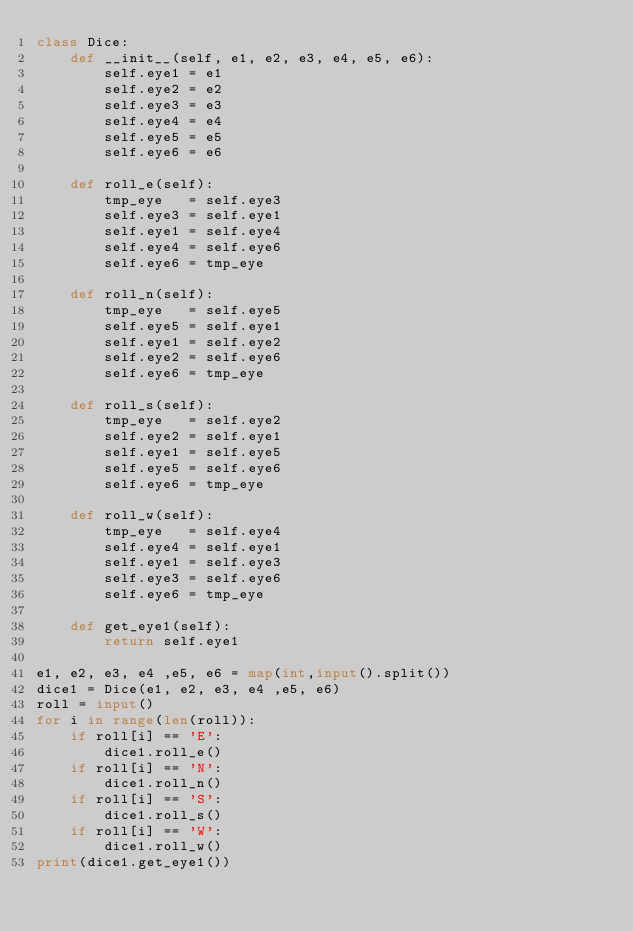Convert code to text. <code><loc_0><loc_0><loc_500><loc_500><_Python_>class Dice:
    def __init__(self, e1, e2, e3, e4, e5, e6):
        self.eye1 = e1
        self.eye2 = e2
        self.eye3 = e3
        self.eye4 = e4
        self.eye5 = e5
        self.eye6 = e6
    
    def roll_e(self):
        tmp_eye   = self.eye3
        self.eye3 = self.eye1
        self.eye1 = self.eye4
        self.eye4 = self.eye6
        self.eye6 = tmp_eye
    
    def roll_n(self):
        tmp_eye   = self.eye5
        self.eye5 = self.eye1
        self.eye1 = self.eye2
        self.eye2 = self.eye6
        self.eye6 = tmp_eye
    
    def roll_s(self):
        tmp_eye   = self.eye2
        self.eye2 = self.eye1
        self.eye1 = self.eye5
        self.eye5 = self.eye6
        self.eye6 = tmp_eye
    
    def roll_w(self):
        tmp_eye   = self.eye4
        self.eye4 = self.eye1
        self.eye1 = self.eye3
        self.eye3 = self.eye6
        self.eye6 = tmp_eye
    
    def get_eye1(self):
        return self.eye1

e1, e2, e3, e4 ,e5, e6 = map(int,input().split())
dice1 = Dice(e1, e2, e3, e4 ,e5, e6)
roll = input()
for i in range(len(roll)):
    if roll[i] == 'E':
        dice1.roll_e()
    if roll[i] == 'N':
        dice1.roll_n()
    if roll[i] == 'S':
        dice1.roll_s()
    if roll[i] == 'W':
        dice1.roll_w()
print(dice1.get_eye1())
</code> 